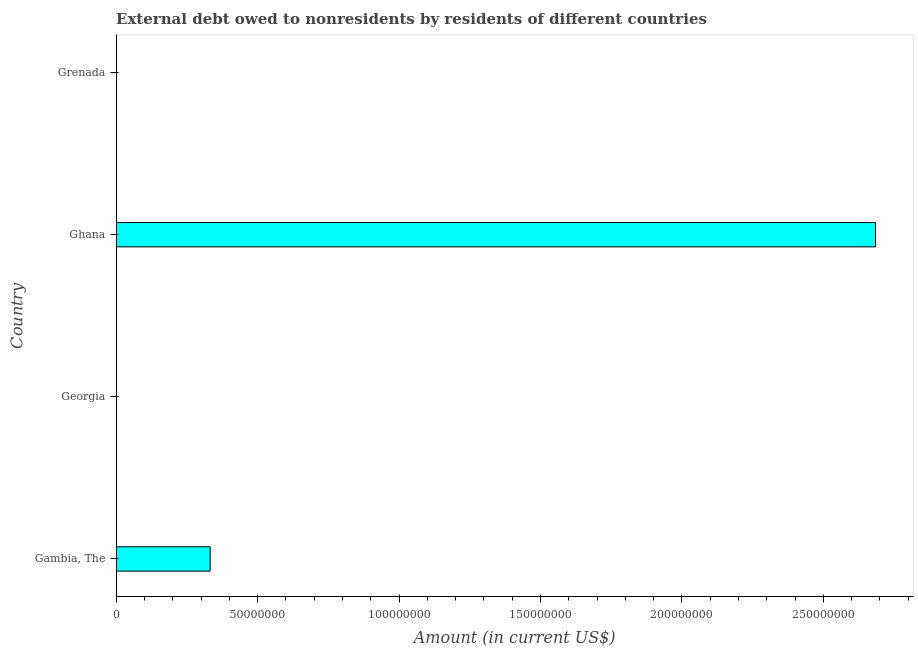Does the graph contain any zero values?
Ensure brevity in your answer.  Yes. What is the title of the graph?
Make the answer very short. External debt owed to nonresidents by residents of different countries. What is the debt in Gambia, The?
Provide a short and direct response. 3.32e+07. Across all countries, what is the maximum debt?
Your response must be concise. 2.68e+08. Across all countries, what is the minimum debt?
Offer a terse response. 0. What is the sum of the debt?
Ensure brevity in your answer.  3.02e+08. What is the difference between the debt in Gambia, The and Ghana?
Provide a short and direct response. -2.35e+08. What is the average debt per country?
Give a very brief answer. 7.54e+07. What is the median debt?
Give a very brief answer. 1.66e+07. In how many countries, is the debt greater than 200000000 US$?
Your answer should be very brief. 1. Is the difference between the debt in Gambia, The and Ghana greater than the difference between any two countries?
Give a very brief answer. No. Is the sum of the debt in Gambia, The and Ghana greater than the maximum debt across all countries?
Your response must be concise. Yes. What is the difference between the highest and the lowest debt?
Make the answer very short. 2.68e+08. In how many countries, is the debt greater than the average debt taken over all countries?
Provide a short and direct response. 1. How many bars are there?
Offer a terse response. 2. What is the difference between two consecutive major ticks on the X-axis?
Offer a very short reply. 5.00e+07. What is the Amount (in current US$) of Gambia, The?
Make the answer very short. 3.32e+07. What is the Amount (in current US$) of Georgia?
Keep it short and to the point. 0. What is the Amount (in current US$) in Ghana?
Provide a succinct answer. 2.68e+08. What is the difference between the Amount (in current US$) in Gambia, The and Ghana?
Give a very brief answer. -2.35e+08. What is the ratio of the Amount (in current US$) in Gambia, The to that in Ghana?
Provide a short and direct response. 0.12. 